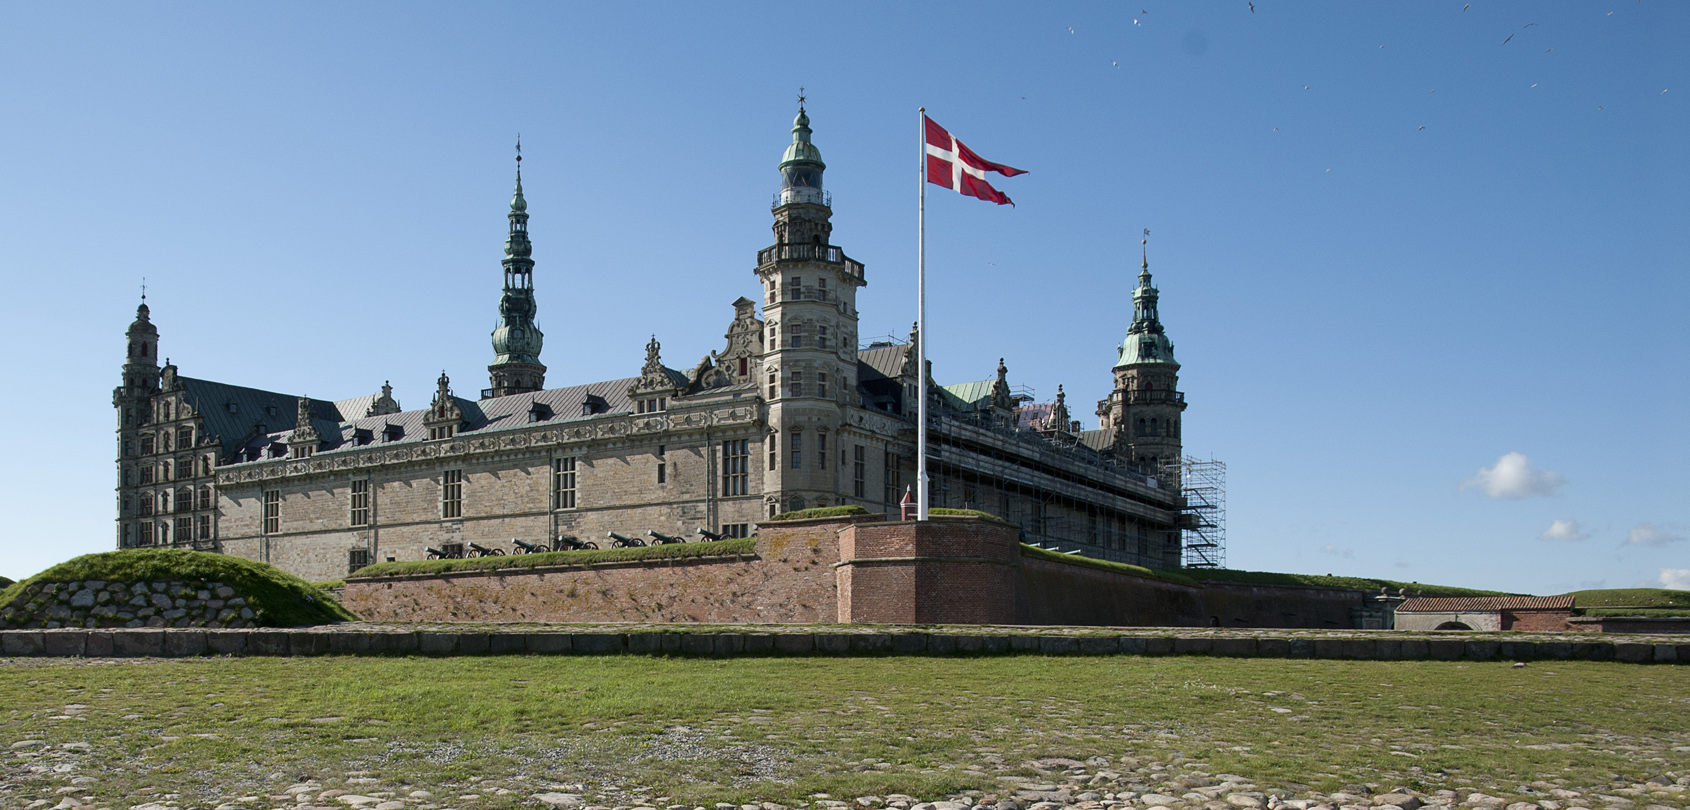Create a brief dialogue between two visitors exploring the castle for the first time. Visitor 1: 'Wow, look at the size of this place! It's like stepping back in time.'
Visitor 2: 'I know, it’s incredible. The craftsmanship on these towers and spires is just stunning. Can you imagine what it would have been like living here?'
Visitor 1: 'Must have been both magnificent and intimidating. The history here is palpable. Hey, did you spot the scaffolding over there?'
Visitor 2: 'Yes, they must be doing restoration work. It’s amazing they’re preserving this piece of history. Oh, and look at the flag! It’s like the castle is still alive with its past glory.'
Visitor 1: 'Absolutely. Let’s go inside next and see the rooms where it all happened.' 